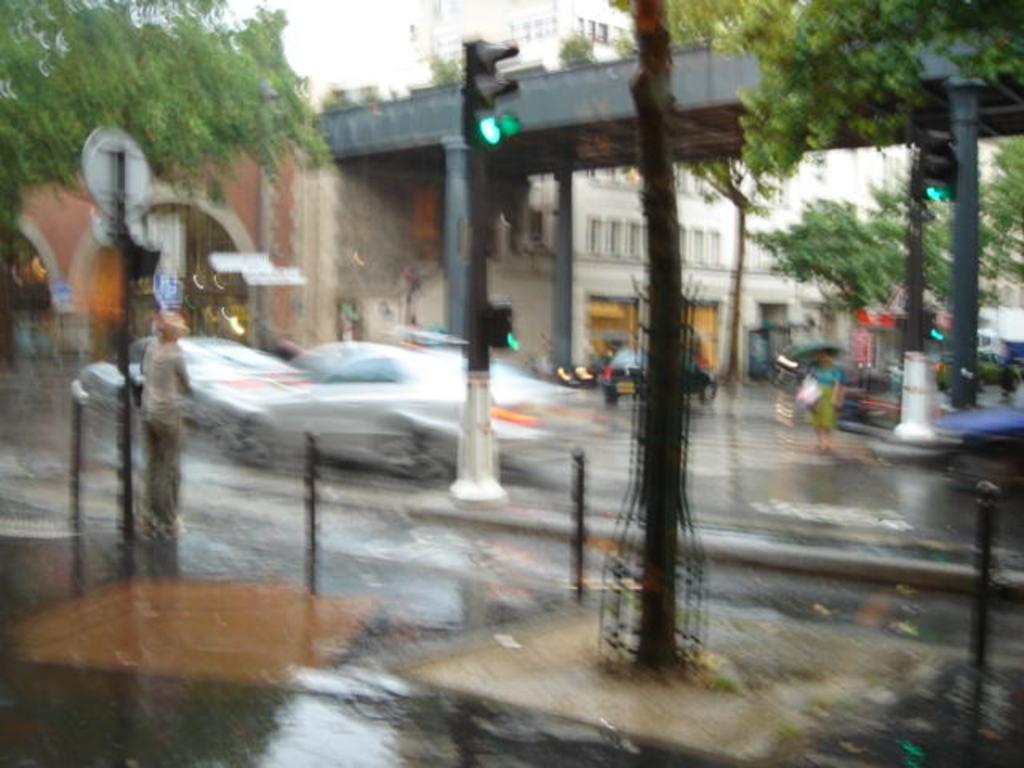Please provide a concise description of this image. There is a person standing on the road on which, there are poles, there is water and there are vehicles. In the background, there is a bridged, there are trees, buildings and there is sky. 